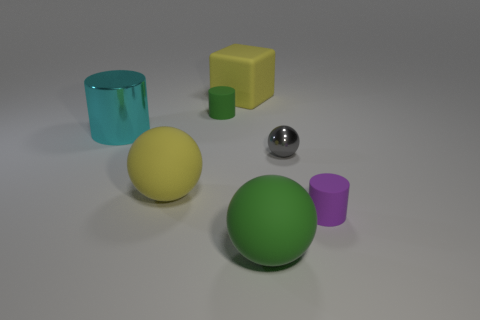Subtract all cyan metallic cylinders. How many cylinders are left? 2 Subtract all gray spheres. How many spheres are left? 2 Subtract 2 spheres. How many spheres are left? 1 Add 1 yellow balls. How many objects exist? 8 Subtract all cyan blocks. Subtract all gray cylinders. How many blocks are left? 1 Subtract all large green rubber spheres. Subtract all large yellow balls. How many objects are left? 5 Add 6 rubber cylinders. How many rubber cylinders are left? 8 Add 6 tiny purple matte objects. How many tiny purple matte objects exist? 7 Subtract 1 yellow blocks. How many objects are left? 6 Subtract all cylinders. How many objects are left? 4 